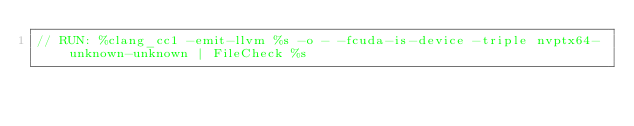<code> <loc_0><loc_0><loc_500><loc_500><_Cuda_>// RUN: %clang_cc1 -emit-llvm %s -o - -fcuda-is-device -triple nvptx64-unknown-unknown | FileCheck %s

</code> 